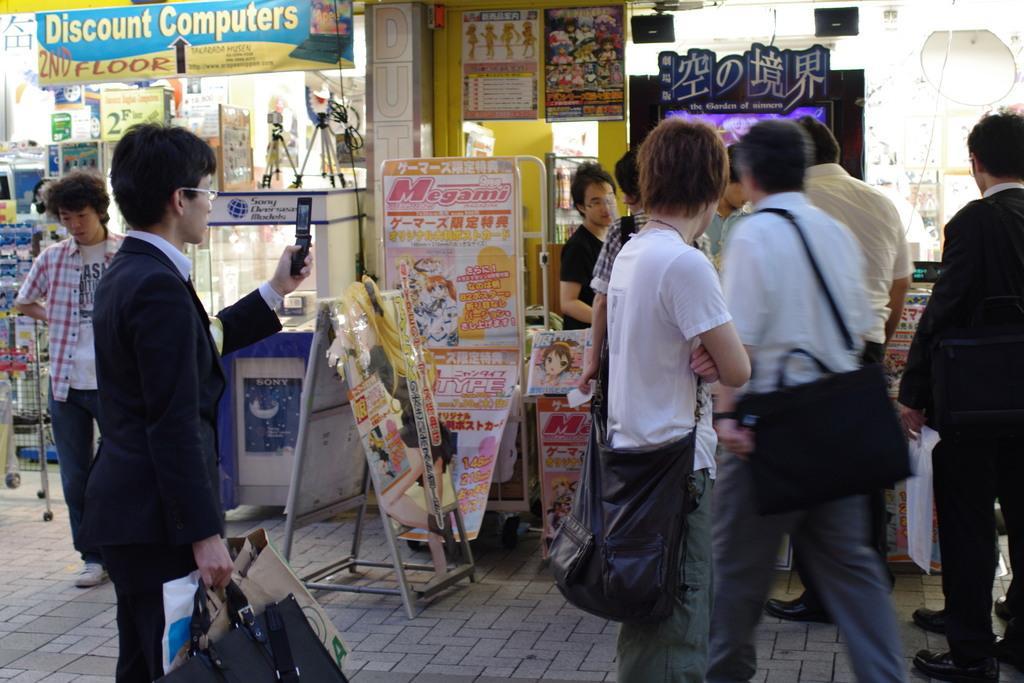Please provide a concise description of this image. On the left side of the image we can see a man standing and holding bags and a mobile in his hands. In the center there are people standing and walking. We can see banners and stalls. At the bottom there is a road. 